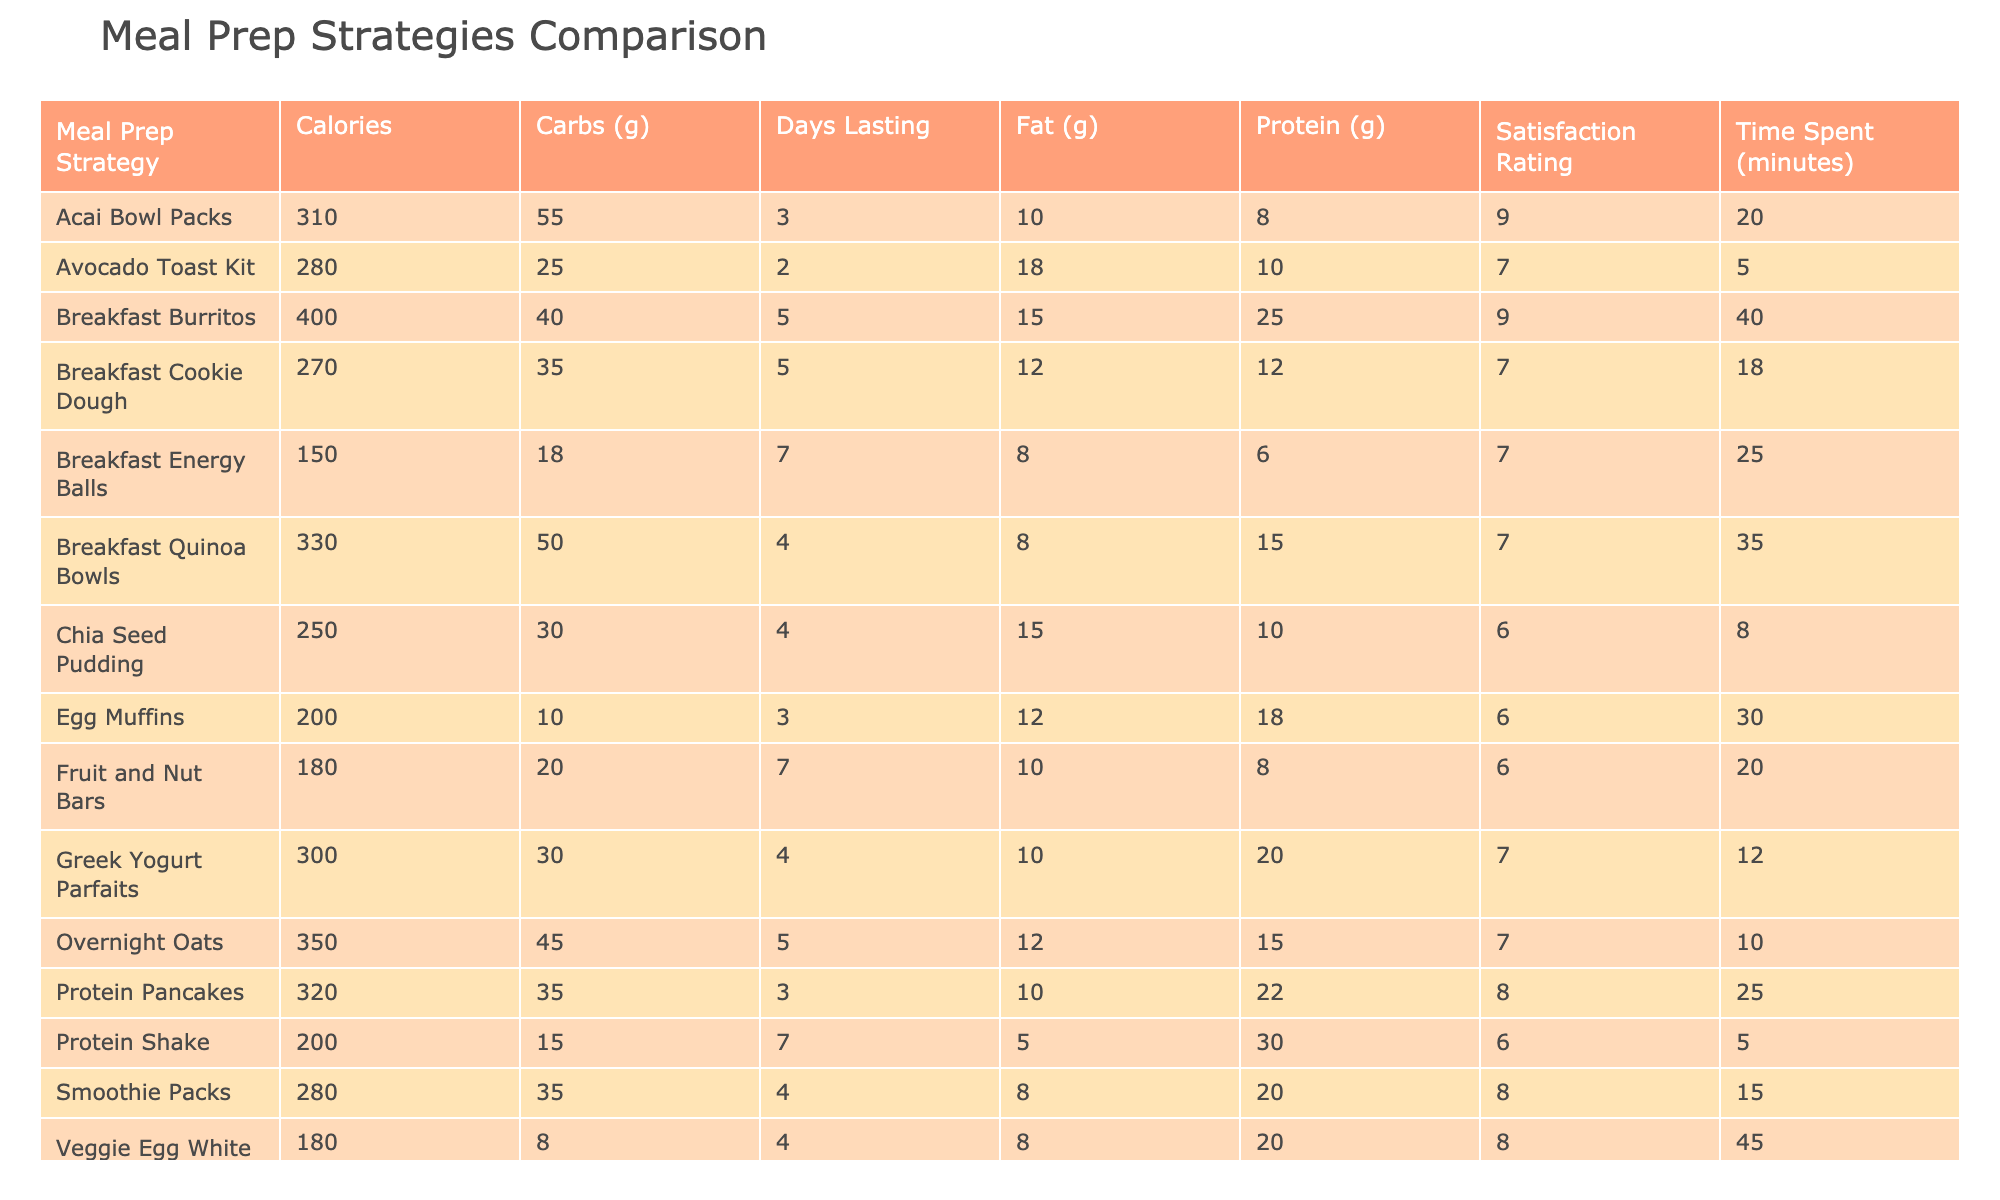What meal prep strategy has the highest satisfaction rating? Looking at the satisfaction ratings of each meal prep strategy, the Breakfast Burritos and Acai Bowl Packs have the highest ratings at 9.
Answer: Breakfast Burritos and Acai Bowl Packs What is the average time spent on meal prep strategies that last more than 5 days? From the table, Breakfast Burritos and Overnight Oats last for 5 days or more. Their total time spent is 10 (Overnight Oats) + 40 (Breakfast Burritos) = 50 minutes. Since there are 2 strategies, the average is 50/2 = 25 minutes.
Answer: 25 minutes Is there a meal prep strategy that has both a high protein content and a low calorie count? Checking the table, the Protein Shake has 200 calories and 30 grams of protein, while no other meal prep strategies with similar calorie content exceed this protein value. Therefore, the Protein Shake is an example of such a strategy.
Answer: Yes, the Protein Shake What is the difference in calories between the meal prep strategies with the highest and lowest calorie counts? The Breakfast Burritos have the highest calories at 400, while the Fruit and Nut Bars have the lowest at 180. The difference is 400 - 180 = 220 calories.
Answer: 220 calories How many meal prep strategies have a satisfaction rating of 7 or higher? The table lists six strategies that have a satisfaction rating of 7 or higher: Overnight Oats, Smoothie Packs, Breakfast Burritos, Acai Bowl Packs, and Protein Pancakes.
Answer: 6 strategies 